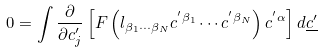Convert formula to latex. <formula><loc_0><loc_0><loc_500><loc_500>0 = \int \frac { \partial } { \partial c ^ { \prime } _ { j } } \left [ F \left ( l _ { \beta _ { 1 } \cdots \beta _ { N } } c ^ { ^ { \prime } \beta _ { 1 } } \cdots c ^ { ^ { \prime } \beta _ { N } } \right ) c ^ { ^ { \prime } \alpha } \right ] d \underline { c ^ { \prime } }</formula> 